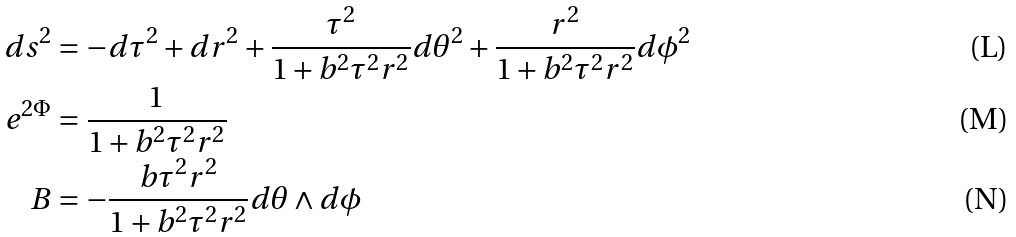Convert formula to latex. <formula><loc_0><loc_0><loc_500><loc_500>d s ^ { 2 } & = - d \tau ^ { 2 } + d r ^ { 2 } + \frac { \tau ^ { 2 } } { 1 + b ^ { 2 } \tau ^ { 2 } r ^ { 2 } } d \theta ^ { 2 } + \frac { r ^ { 2 } } { 1 + b ^ { 2 } \tau ^ { 2 } r ^ { 2 } } d \phi ^ { 2 } \\ e ^ { 2 \Phi } & = \frac { 1 } { 1 + b ^ { 2 } \tau ^ { 2 } r ^ { 2 } } \\ B & = - \frac { b \tau ^ { 2 } r ^ { 2 } } { 1 + b ^ { 2 } \tau ^ { 2 } r ^ { 2 } } d \theta \wedge d \phi</formula> 